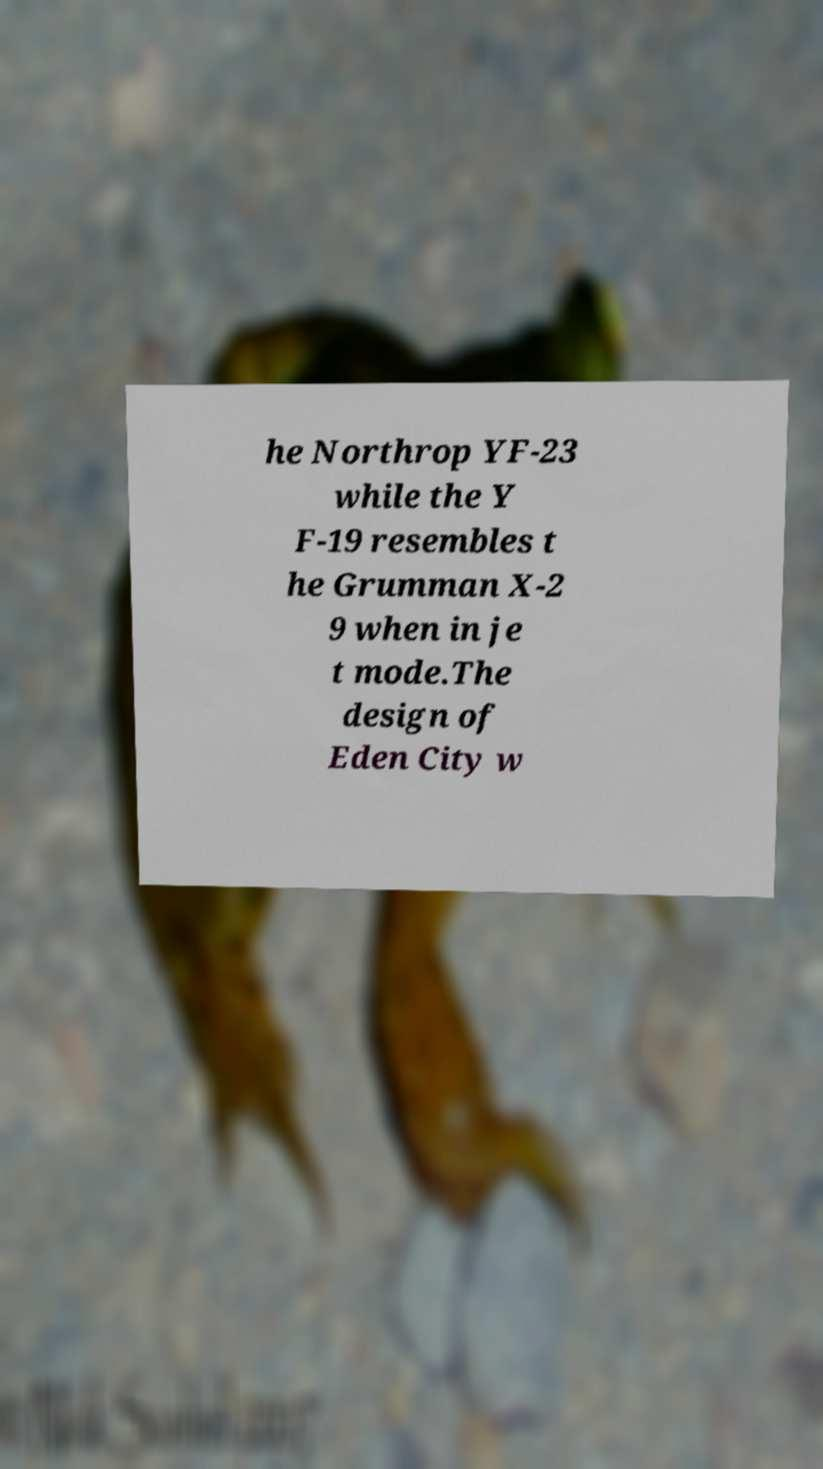I need the written content from this picture converted into text. Can you do that? he Northrop YF-23 while the Y F-19 resembles t he Grumman X-2 9 when in je t mode.The design of Eden City w 